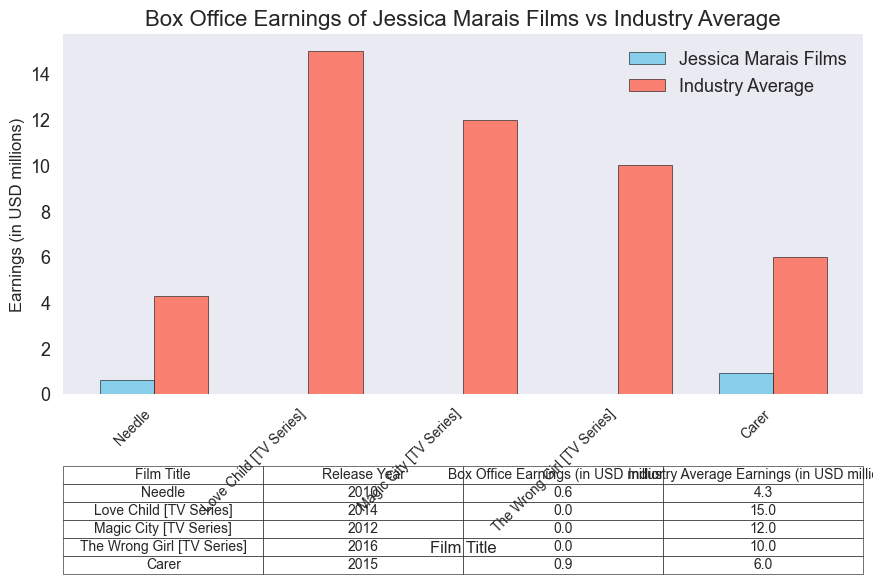What's the total box office earnings for Jessica Marais' films in this chart? Add up the box office earnings for all listed films/series starring Jessica Marais: "Needle" (0.6), "Love Child [TV Series]" (0.0), "Magic City [TV Series]" (0.0), "The Wrong Girl [TV Series]" (0.0), "Carer" (0.9). Summing these values: 0.6 + 0.0 + 0.0 + 0.0 + 0.9 = 1.5.
Answer: 1.5 Which film/series had the highest box office earnings for Jessica Marais? Look at the bar heights and the table data for all films/series starring Jessica Marais. "Carer" has the highest earnings of 0.9 million USD.
Answer: Carer How does the industry average for "Needle" compare to its actual earnings? Compare the heights of the bars for "Needle". The industry average is significantly higher at 4.3 million USD compared to 0.6 million USD for "Needle".
Answer: Industry average is higher Which series featuring Jessica Marais had zero box office earnings? Identify the series with zero box office earnings by looking at the table or the plot bars. "Love Child [TV Series]", "Magic City [TV Series]", and "The Wrong Girl [TV Series]" all have zero earnings.
Answer: Love Child [TV Series], Magic City [TV Series], The Wrong Girl [TV Series] How does the total box office earnings for Jessica Marais' films compare to the total industry average? Add up the industry average earnings: 4.3 + 15.0 + 12.0 + 10.0 + 6.0 = 47.3. Then compare it to the total box office earnings of Jessica Marais' films, which is 1.5. 47.3 is far greater than 1.5.
Answer: Industry average is higher Which release year had the lowest box office earnings for Jessica Marais? Check the table and bar graph for the year with the lowest earnings where earnings are not zero. "Needle" in 2010 had earnings of 0.6 million USD, which is the lowest non-zero value.
Answer: 2010 What is the average industry earnings for the listed films/series? Sum the industry average earnings given in the table: (4.3 + 15.0 + 12.0 + 10.0 + 6.0) = 47.3. There are 5 data points, so divide the total by 5: 47.3 / 5 = 9.46 million USD.
Answer: 9.46 How much greater was the industry average earnings for "Carer" compared to its actual earnings? The industry average for "Carer" is 6.0 million USD, and its actual earnings are 0.9 million USD. The difference is 6.0 - 0.9 = 5.1 million USD.
Answer: 5.1 